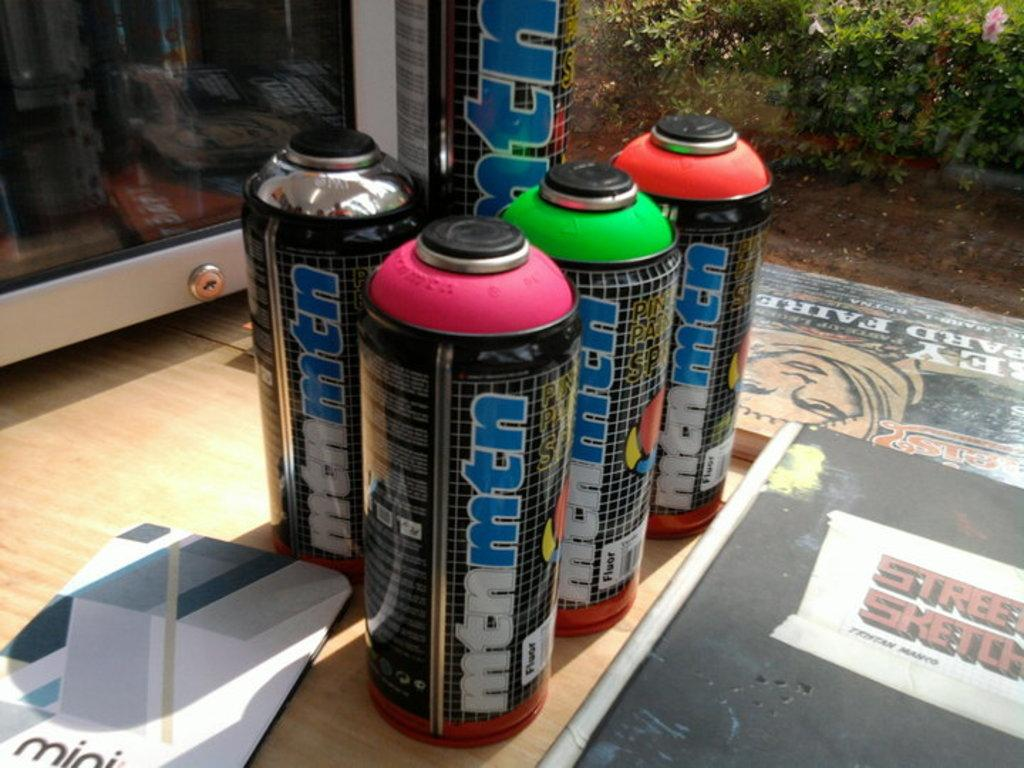<image>
Share a concise interpretation of the image provided. A few cans of different colors called mtnmtn 